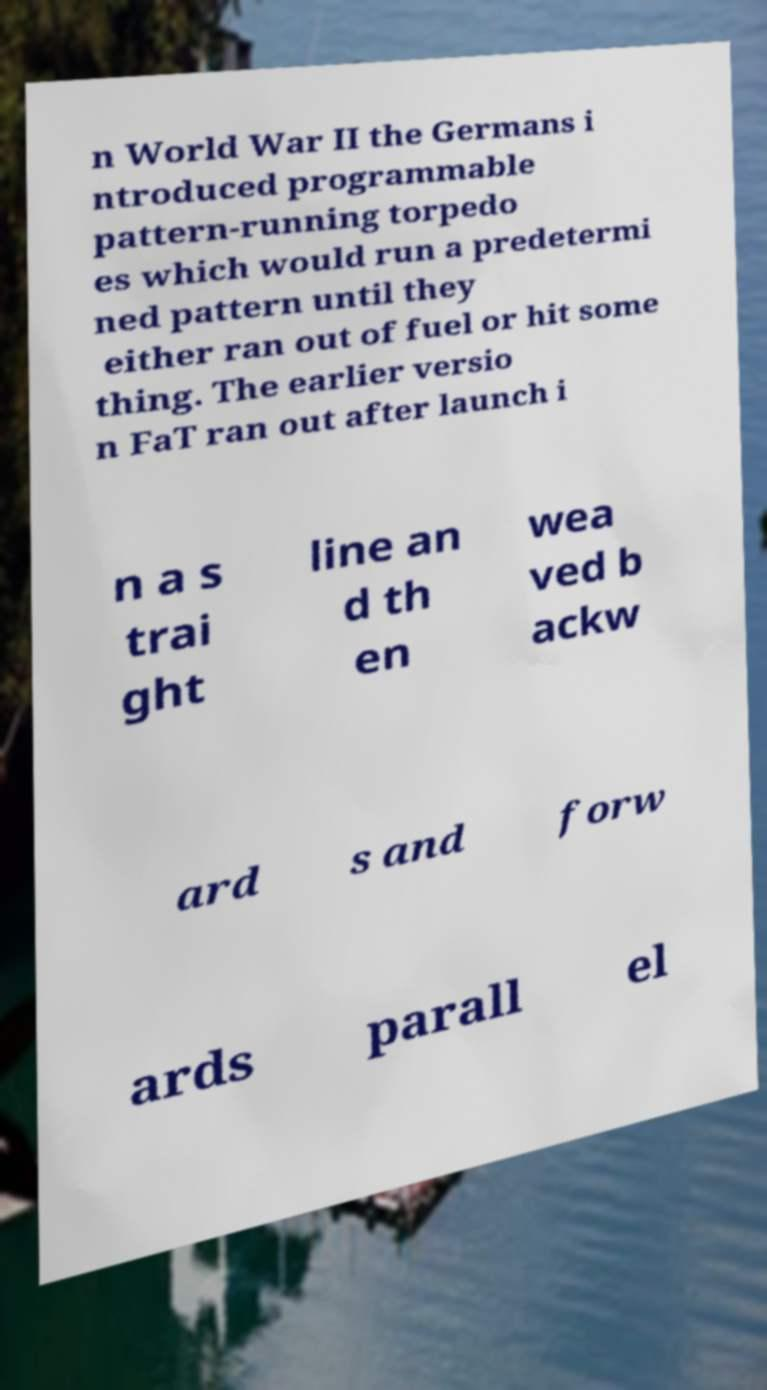Can you read and provide the text displayed in the image?This photo seems to have some interesting text. Can you extract and type it out for me? n World War II the Germans i ntroduced programmable pattern-running torpedo es which would run a predetermi ned pattern until they either ran out of fuel or hit some thing. The earlier versio n FaT ran out after launch i n a s trai ght line an d th en wea ved b ackw ard s and forw ards parall el 